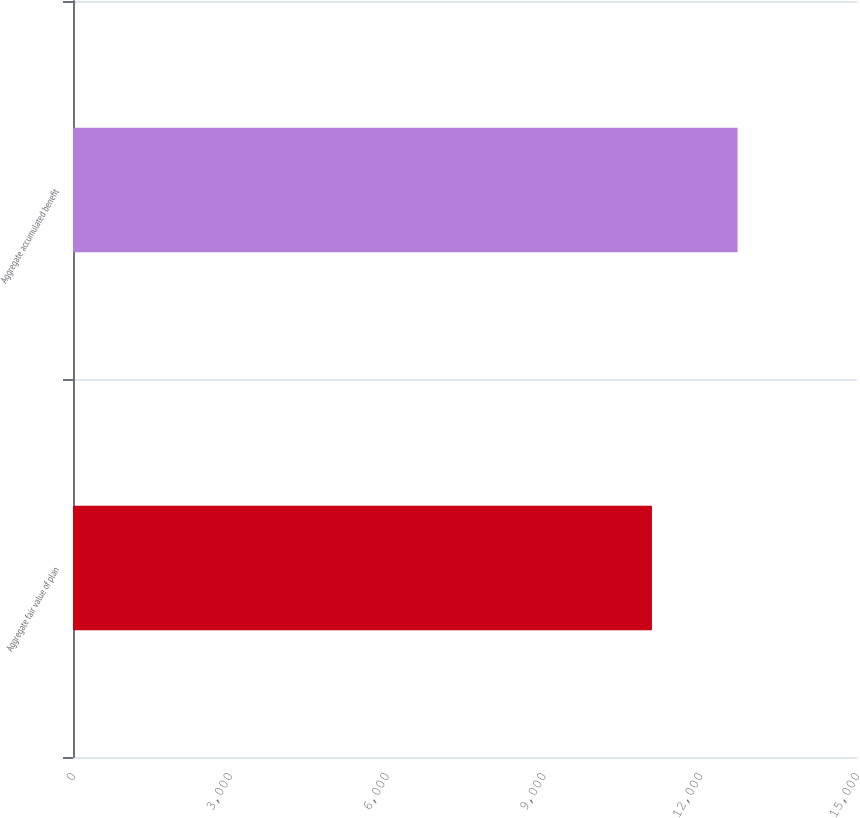Convert chart. <chart><loc_0><loc_0><loc_500><loc_500><bar_chart><fcel>Aggregate fair value of plan<fcel>Aggregate accumulated benefit<nl><fcel>11077<fcel>12715<nl></chart> 